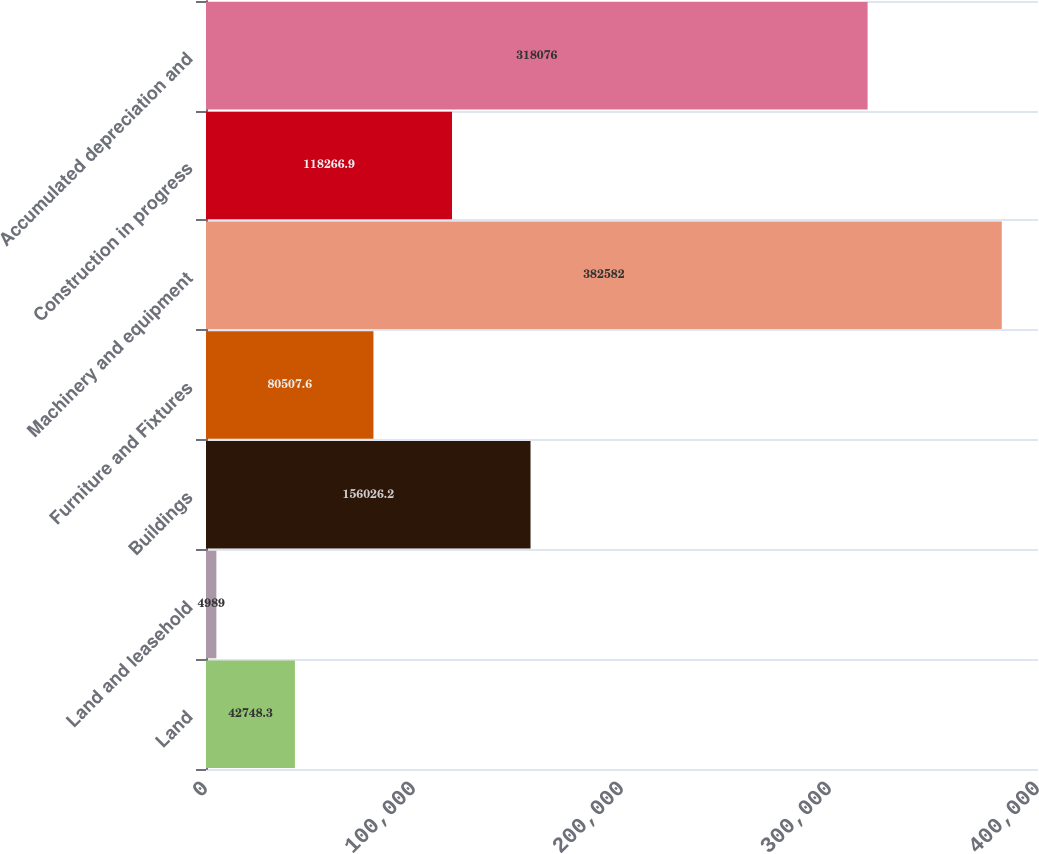Convert chart to OTSL. <chart><loc_0><loc_0><loc_500><loc_500><bar_chart><fcel>Land<fcel>Land and leasehold<fcel>Buildings<fcel>Furniture and Fixtures<fcel>Machinery and equipment<fcel>Construction in progress<fcel>Accumulated depreciation and<nl><fcel>42748.3<fcel>4989<fcel>156026<fcel>80507.6<fcel>382582<fcel>118267<fcel>318076<nl></chart> 